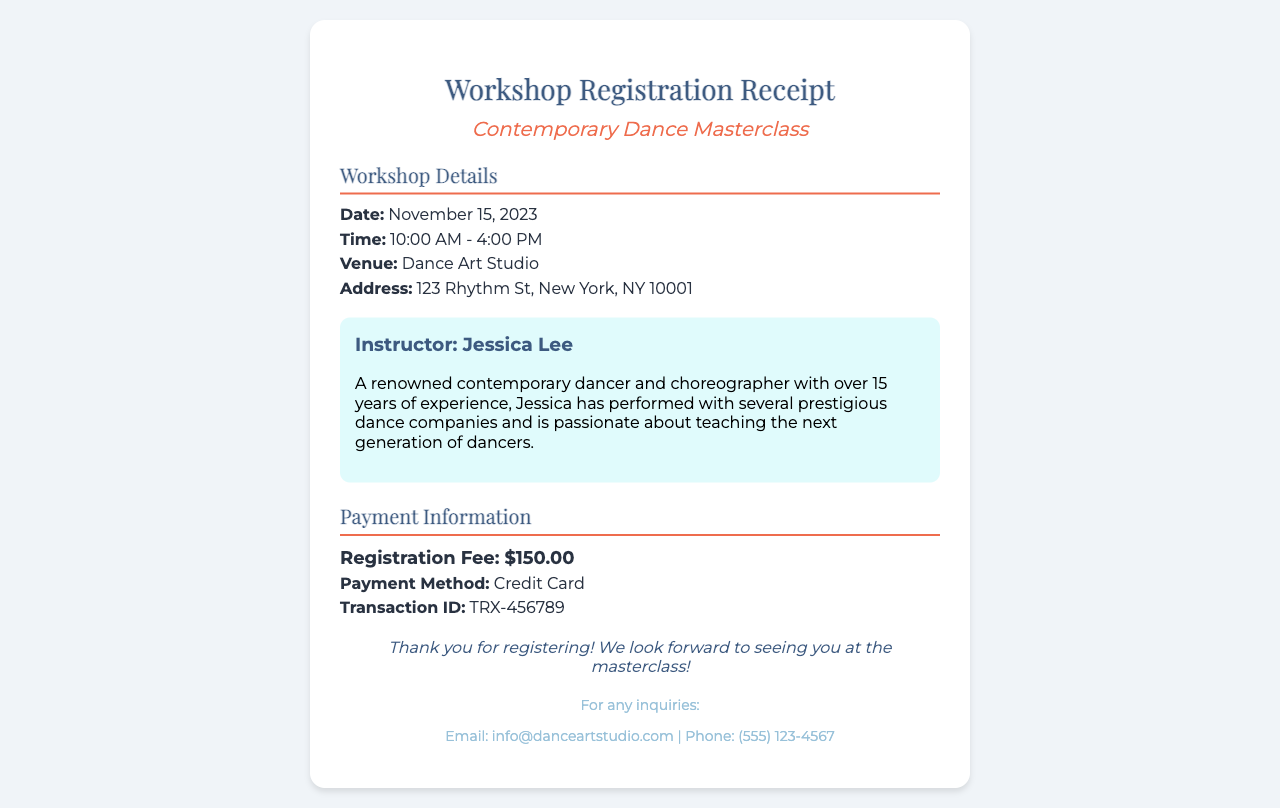what is the date of the workshop? The date of the workshop is mentioned under the Workshop Details section in the document.
Answer: November 15, 2023 what is the venue for the masterclass? The venue is specified in the Workshop Details section, indicating where the event will take place.
Answer: Dance Art Studio who is the instructor for the masterclass? The instructor's name is provided in the instructor section of the document, detailing who will be leading the class.
Answer: Jessica Lee how much is the registration fee? The registration fee is specified under the Payment Information section, providing the cost to register for the workshop.
Answer: $150.00 what is the payment method used for the registration? The payment method is indicated in the Payment Information section, explaining how the fee was paid.
Answer: Credit Card what time does the workshop start? The starting time of the workshop is mentioned in the Workshop Details section, informing participants when the event begins.
Answer: 10:00 AM what is the address of the venue? The address of the venue is listed in the Workshop Details section, giving specific location information.
Answer: 123 Rhythm St, New York, NY 10001 how long is the masterclass scheduled to last? The duration of the workshop can be determined from the start and end times provided in the Workshop Details section.
Answer: 6 hours what is the transaction ID for the registration payment? The transaction ID is found in the Payment Information section, allowing for reference to the specific payment made.
Answer: TRX-456789 